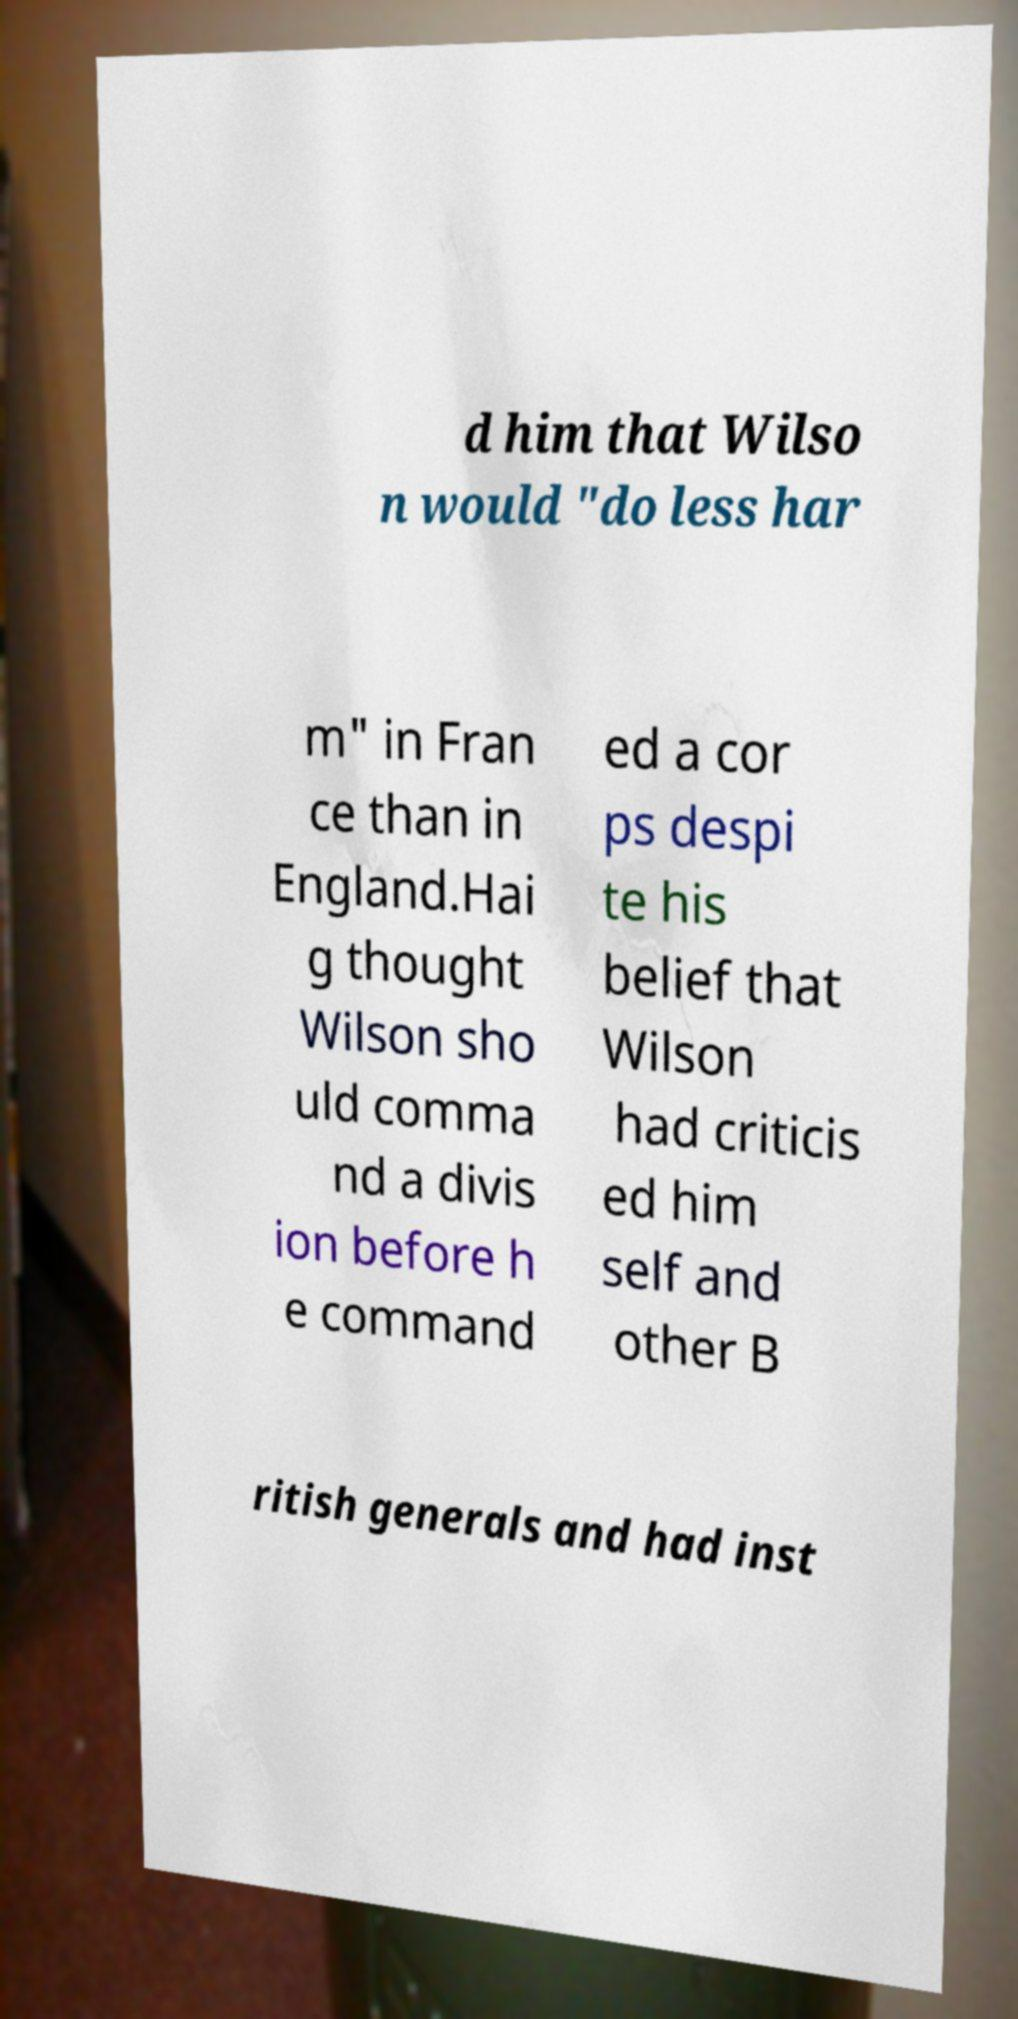For documentation purposes, I need the text within this image transcribed. Could you provide that? d him that Wilso n would "do less har m" in Fran ce than in England.Hai g thought Wilson sho uld comma nd a divis ion before h e command ed a cor ps despi te his belief that Wilson had criticis ed him self and other B ritish generals and had inst 